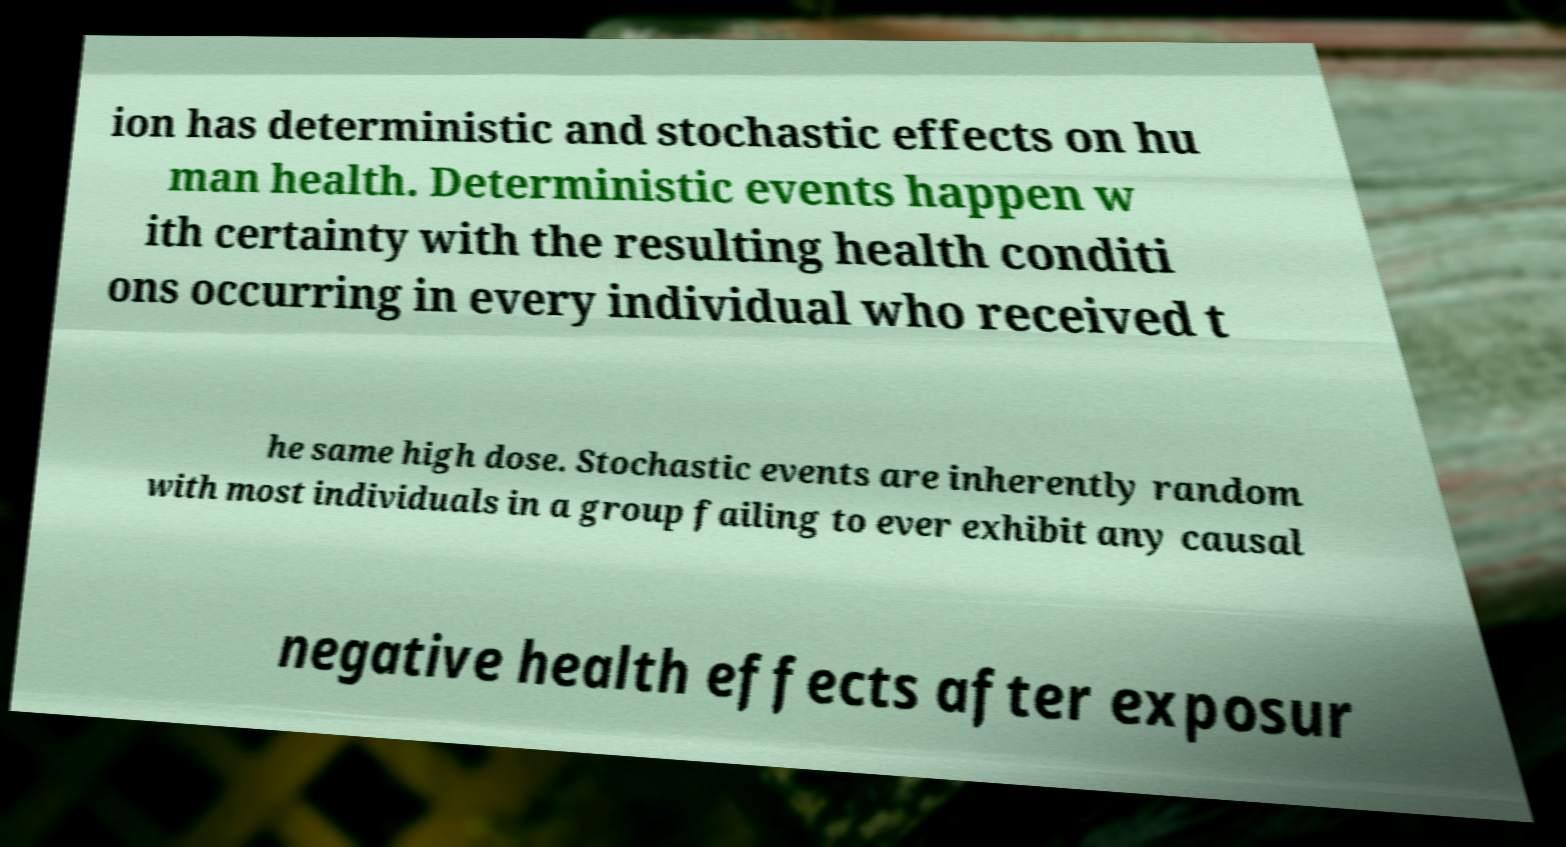Could you assist in decoding the text presented in this image and type it out clearly? ion has deterministic and stochastic effects on hu man health. Deterministic events happen w ith certainty with the resulting health conditi ons occurring in every individual who received t he same high dose. Stochastic events are inherently random with most individuals in a group failing to ever exhibit any causal negative health effects after exposur 